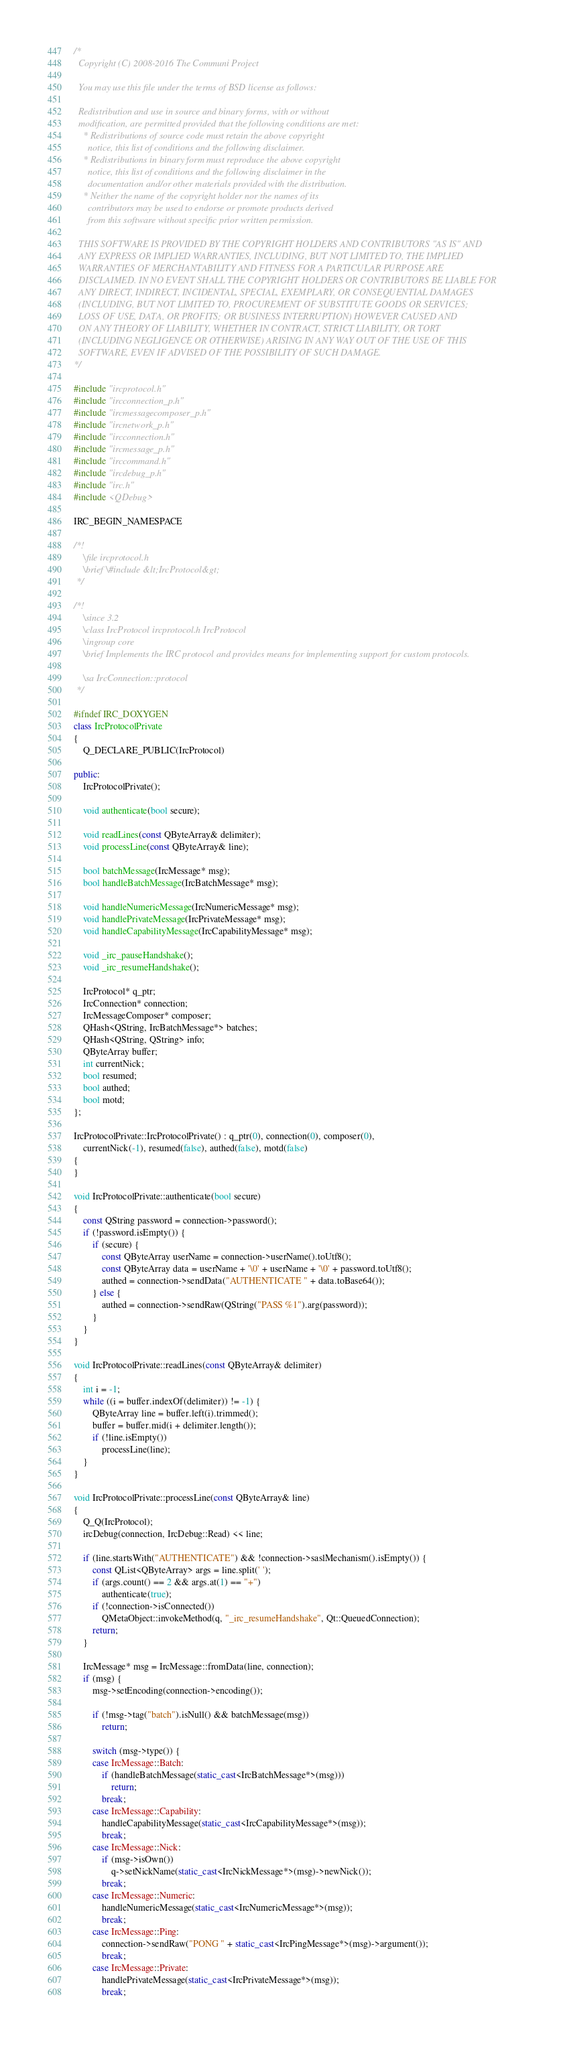Convert code to text. <code><loc_0><loc_0><loc_500><loc_500><_C++_>/*
  Copyright (C) 2008-2016 The Communi Project

  You may use this file under the terms of BSD license as follows:

  Redistribution and use in source and binary forms, with or without
  modification, are permitted provided that the following conditions are met:
    * Redistributions of source code must retain the above copyright
      notice, this list of conditions and the following disclaimer.
    * Redistributions in binary form must reproduce the above copyright
      notice, this list of conditions and the following disclaimer in the
      documentation and/or other materials provided with the distribution.
    * Neither the name of the copyright holder nor the names of its
      contributors may be used to endorse or promote products derived
      from this software without specific prior written permission.

  THIS SOFTWARE IS PROVIDED BY THE COPYRIGHT HOLDERS AND CONTRIBUTORS "AS IS" AND
  ANY EXPRESS OR IMPLIED WARRANTIES, INCLUDING, BUT NOT LIMITED TO, THE IMPLIED
  WARRANTIES OF MERCHANTABILITY AND FITNESS FOR A PARTICULAR PURPOSE ARE
  DISCLAIMED. IN NO EVENT SHALL THE COPYRIGHT HOLDERS OR CONTRIBUTORS BE LIABLE FOR
  ANY DIRECT, INDIRECT, INCIDENTAL, SPECIAL, EXEMPLARY, OR CONSEQUENTIAL DAMAGES
  (INCLUDING, BUT NOT LIMITED TO, PROCUREMENT OF SUBSTITUTE GOODS OR SERVICES;
  LOSS OF USE, DATA, OR PROFITS; OR BUSINESS INTERRUPTION) HOWEVER CAUSED AND
  ON ANY THEORY OF LIABILITY, WHETHER IN CONTRACT, STRICT LIABILITY, OR TORT
  (INCLUDING NEGLIGENCE OR OTHERWISE) ARISING IN ANY WAY OUT OF THE USE OF THIS
  SOFTWARE, EVEN IF ADVISED OF THE POSSIBILITY OF SUCH DAMAGE.
*/

#include "ircprotocol.h"
#include "ircconnection_p.h"
#include "ircmessagecomposer_p.h"
#include "ircnetwork_p.h"
#include "ircconnection.h"
#include "ircmessage_p.h"
#include "irccommand.h"
#include "ircdebug_p.h"
#include "irc.h"
#include <QDebug>

IRC_BEGIN_NAMESPACE

/*!
    \file ircprotocol.h
    \brief \#include &lt;IrcProtocol&gt;
 */

/*!
    \since 3.2
    \class IrcProtocol ircprotocol.h IrcProtocol
    \ingroup core
    \brief Implements the IRC protocol and provides means for implementing support for custom protocols.

    \sa IrcConnection::protocol
 */

#ifndef IRC_DOXYGEN
class IrcProtocolPrivate
{
    Q_DECLARE_PUBLIC(IrcProtocol)

public:
    IrcProtocolPrivate();

    void authenticate(bool secure);

    void readLines(const QByteArray& delimiter);
    void processLine(const QByteArray& line);

    bool batchMessage(IrcMessage* msg);
    bool handleBatchMessage(IrcBatchMessage* msg);

    void handleNumericMessage(IrcNumericMessage* msg);
    void handlePrivateMessage(IrcPrivateMessage* msg);
    void handleCapabilityMessage(IrcCapabilityMessage* msg);

    void _irc_pauseHandshake();
    void _irc_resumeHandshake();

    IrcProtocol* q_ptr;
    IrcConnection* connection;
    IrcMessageComposer* composer;
    QHash<QString, IrcBatchMessage*> batches;
    QHash<QString, QString> info;
    QByteArray buffer;
    int currentNick;
    bool resumed;
    bool authed;
    bool motd;
};

IrcProtocolPrivate::IrcProtocolPrivate() : q_ptr(0), connection(0), composer(0),
    currentNick(-1), resumed(false), authed(false), motd(false)
{
}

void IrcProtocolPrivate::authenticate(bool secure)
{
    const QString password = connection->password();
    if (!password.isEmpty()) {
        if (secure) {
            const QByteArray userName = connection->userName().toUtf8();
            const QByteArray data = userName + '\0' + userName + '\0' + password.toUtf8();
            authed = connection->sendData("AUTHENTICATE " + data.toBase64());
        } else {
            authed = connection->sendRaw(QString("PASS %1").arg(password));
        }
    }
}

void IrcProtocolPrivate::readLines(const QByteArray& delimiter)
{
    int i = -1;
    while ((i = buffer.indexOf(delimiter)) != -1) {
        QByteArray line = buffer.left(i).trimmed();
        buffer = buffer.mid(i + delimiter.length());
        if (!line.isEmpty())
            processLine(line);
    }
}

void IrcProtocolPrivate::processLine(const QByteArray& line)
{
    Q_Q(IrcProtocol);
    ircDebug(connection, IrcDebug::Read) << line;

    if (line.startsWith("AUTHENTICATE") && !connection->saslMechanism().isEmpty()) {
        const QList<QByteArray> args = line.split(' ');
        if (args.count() == 2 && args.at(1) == "+")
            authenticate(true);
        if (!connection->isConnected())
            QMetaObject::invokeMethod(q, "_irc_resumeHandshake", Qt::QueuedConnection);
        return;
    }

    IrcMessage* msg = IrcMessage::fromData(line, connection);
    if (msg) {
        msg->setEncoding(connection->encoding());

        if (!msg->tag("batch").isNull() && batchMessage(msg))
            return;

        switch (msg->type()) {
        case IrcMessage::Batch:
            if (handleBatchMessage(static_cast<IrcBatchMessage*>(msg)))
                return;
            break;
        case IrcMessage::Capability:
            handleCapabilityMessage(static_cast<IrcCapabilityMessage*>(msg));
            break;
        case IrcMessage::Nick:
            if (msg->isOwn())
                q->setNickName(static_cast<IrcNickMessage*>(msg)->newNick());
            break;
        case IrcMessage::Numeric:
            handleNumericMessage(static_cast<IrcNumericMessage*>(msg));
            break;
        case IrcMessage::Ping:
            connection->sendRaw("PONG " + static_cast<IrcPingMessage*>(msg)->argument());
            break;
        case IrcMessage::Private:
            handlePrivateMessage(static_cast<IrcPrivateMessage*>(msg));
            break;</code> 